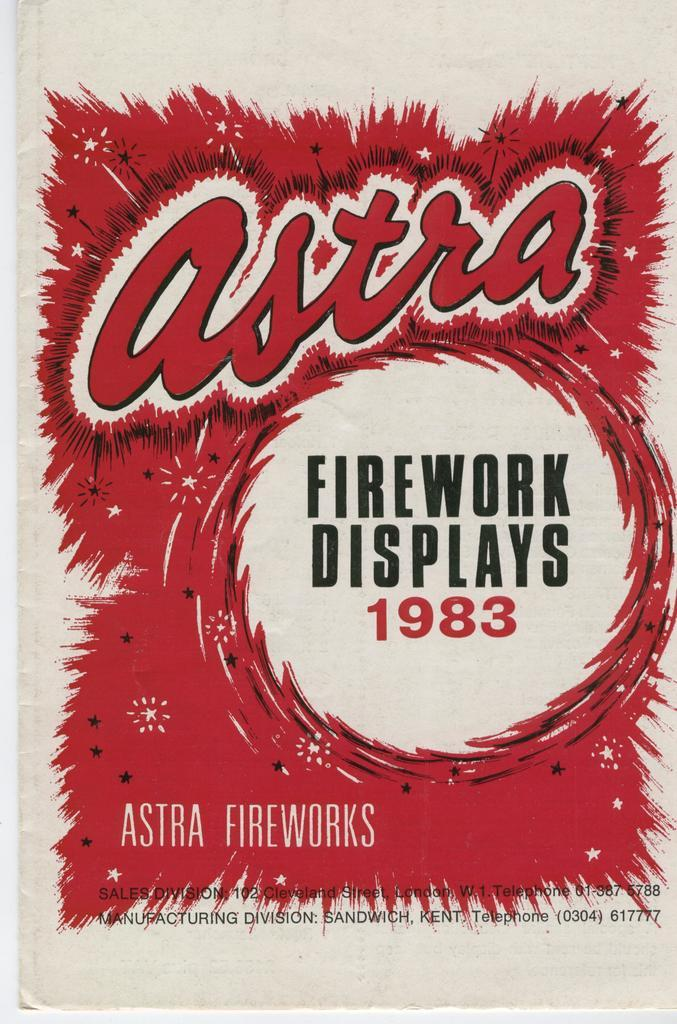<image>
Offer a succinct explanation of the picture presented. a sign display that says firework displays 1983 